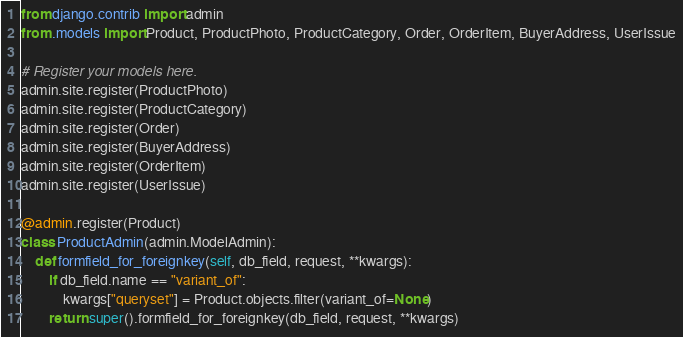Convert code to text. <code><loc_0><loc_0><loc_500><loc_500><_Python_>from django.contrib import admin
from .models import Product, ProductPhoto, ProductCategory, Order, OrderItem, BuyerAddress, UserIssue

# Register your models here.
admin.site.register(ProductPhoto)
admin.site.register(ProductCategory)
admin.site.register(Order)
admin.site.register(BuyerAddress)
admin.site.register(OrderItem)
admin.site.register(UserIssue)

@admin.register(Product)
class ProductAdmin(admin.ModelAdmin):
    def formfield_for_foreignkey(self, db_field, request, **kwargs):
        if db_field.name == "variant_of":
            kwargs["queryset"] = Product.objects.filter(variant_of=None)
        return super().formfield_for_foreignkey(db_field, request, **kwargs)</code> 